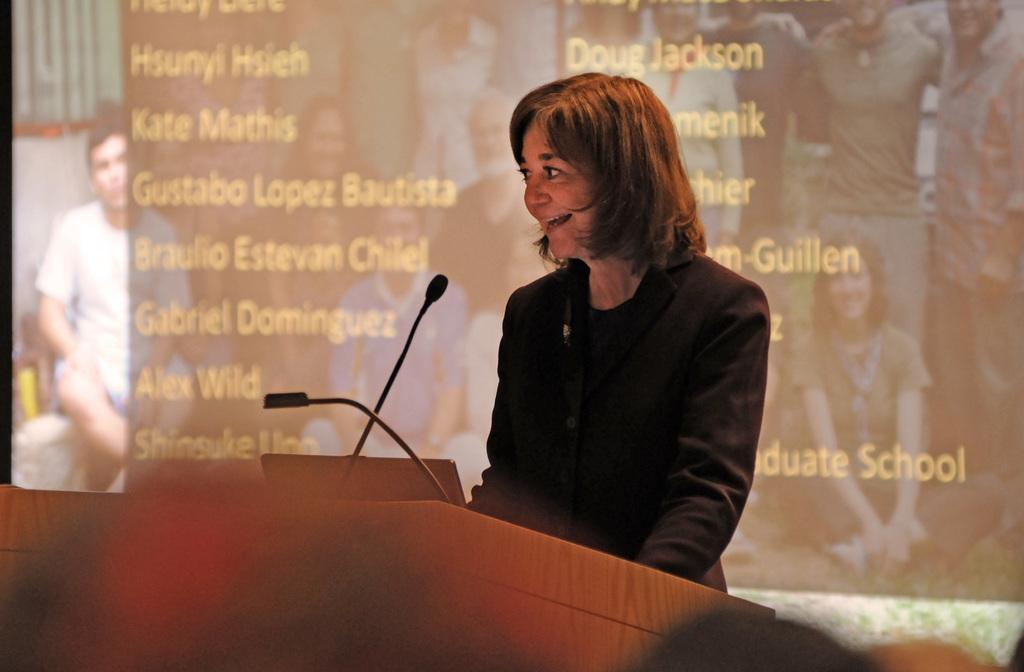Can you describe this image briefly? In this image in front there is a person standing in front of the dais. On top of the days there is a laptop and a mike. In the background of the image there is a screen. 